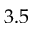<formula> <loc_0><loc_0><loc_500><loc_500>3 . 5</formula> 